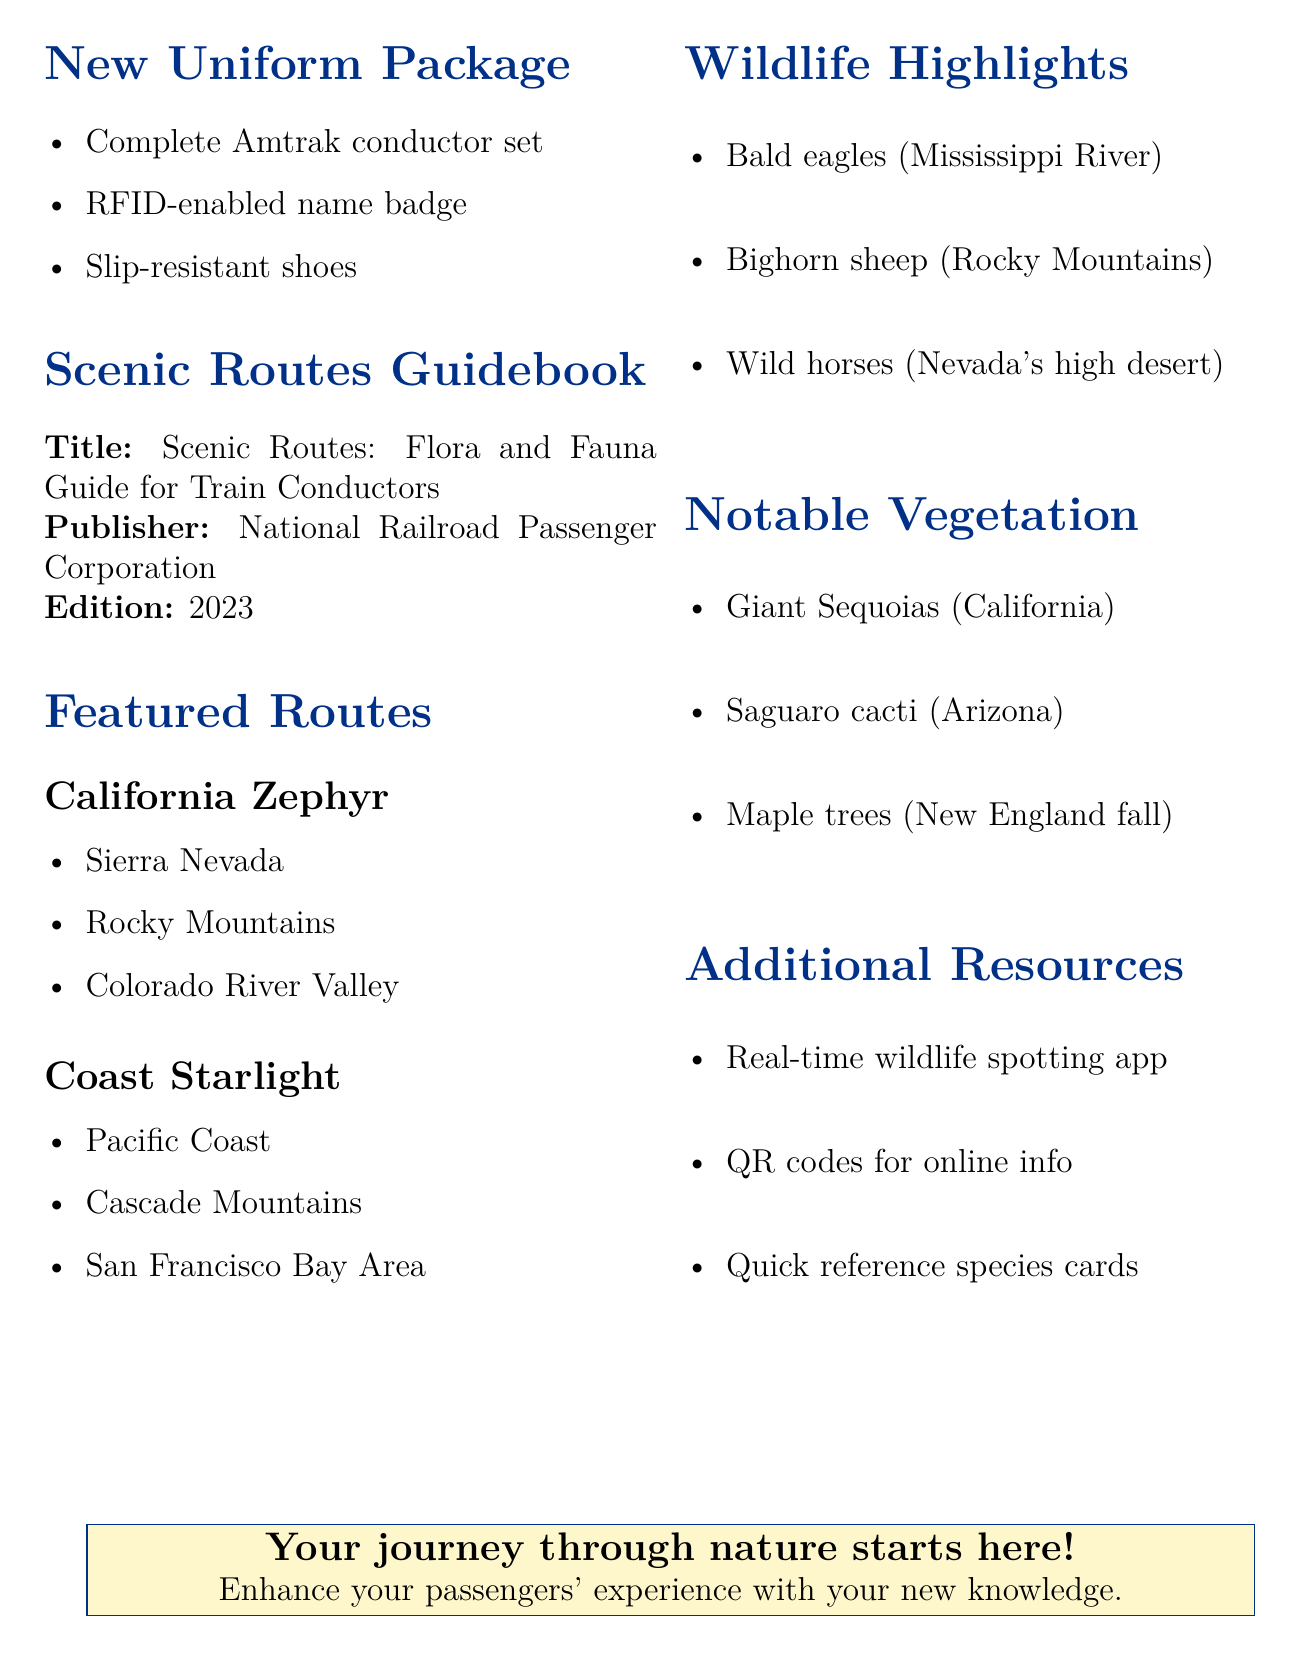What is included in the new uniform package? The new uniform package contains the items listed in the document, specifically a hat, jacket, shirt, trousers, and tie.
Answer: New Amtrak conductor uniform set What is the title of the guidebook? The title of the guidebook is stated clearly in the document.
Answer: Scenic Routes: Flora and Fauna Guide for Train Conductors Who published the guidebook? The publisher of the guidebook is mentioned in the document.
Answer: National Railroad Passenger Corporation Name one scenic route highlighted in the document. The document lists two scenic routes, so one example can be taken from that.
Answer: California Zephyr What type of shoes are included in the new uniform package? The document specifies the type of shoes provided in the uniform package.
Answer: Slip-resistant shoes List one local wildlife species mentioned in the document. The document lists several wildlife species, one can be selected as an example.
Answer: Bald eagles What is the edition of the guidebook? The edition is explicitly mentioned in the document to indicate the version of the guidebook.
Answer: 2023 Edition What type of additional resource is available for wildlife spotting updates? The document highlights a specific mobile app aimed at providing updates related to wildlife.
Answer: Mobile app Which iconic tree is mentioned in the notable vegetation section? The document specifically lists examples of vegetation, including trees, one of which can be chosen.
Answer: Giant Sequoias What color is the accent used in the document header? The document describes the color scheme utilized in the design elements.
Answer: Gold 